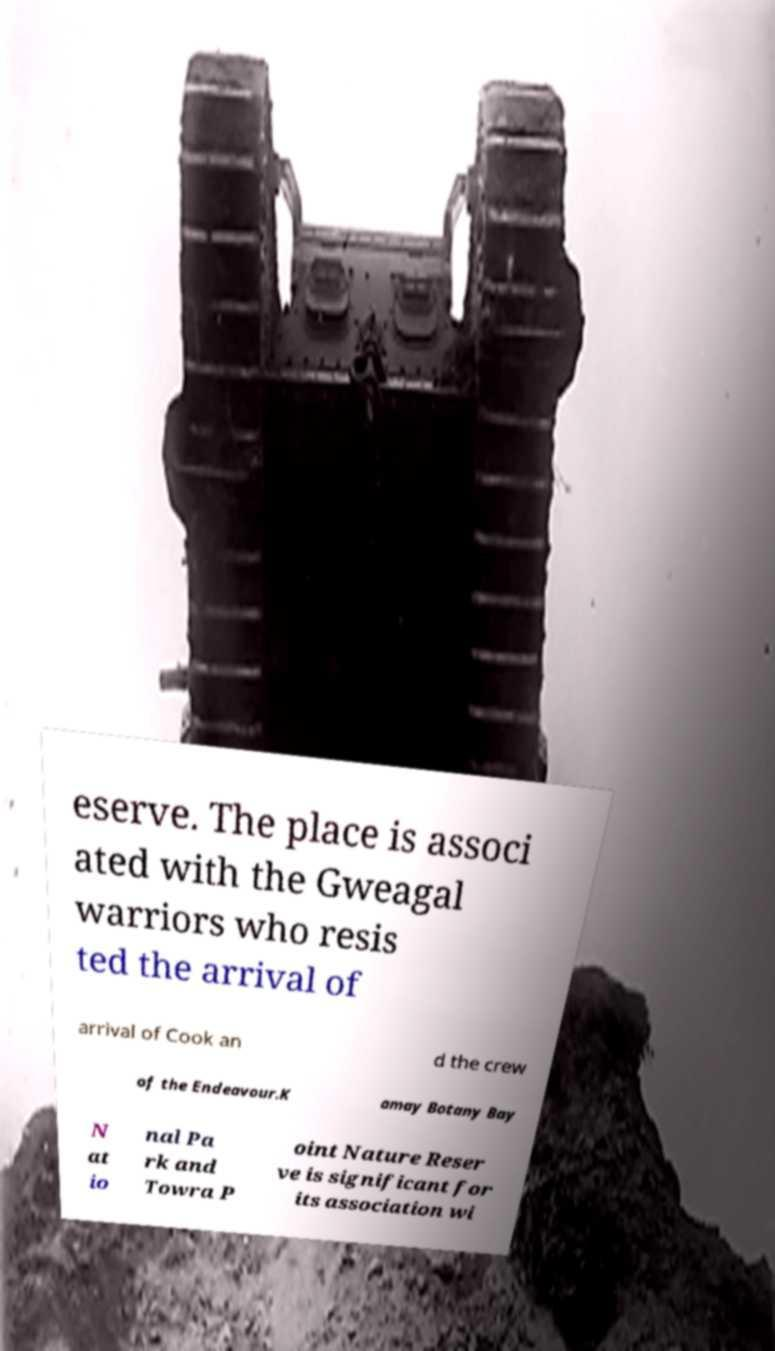Could you assist in decoding the text presented in this image and type it out clearly? eserve. The place is associ ated with the Gweagal warriors who resis ted the arrival of arrival of Cook an d the crew of the Endeavour.K amay Botany Bay N at io nal Pa rk and Towra P oint Nature Reser ve is significant for its association wi 